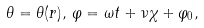Convert formula to latex. <formula><loc_0><loc_0><loc_500><loc_500>\theta = \theta ( r ) , \, \varphi = \omega t + \nu \chi + \varphi _ { 0 } ,</formula> 